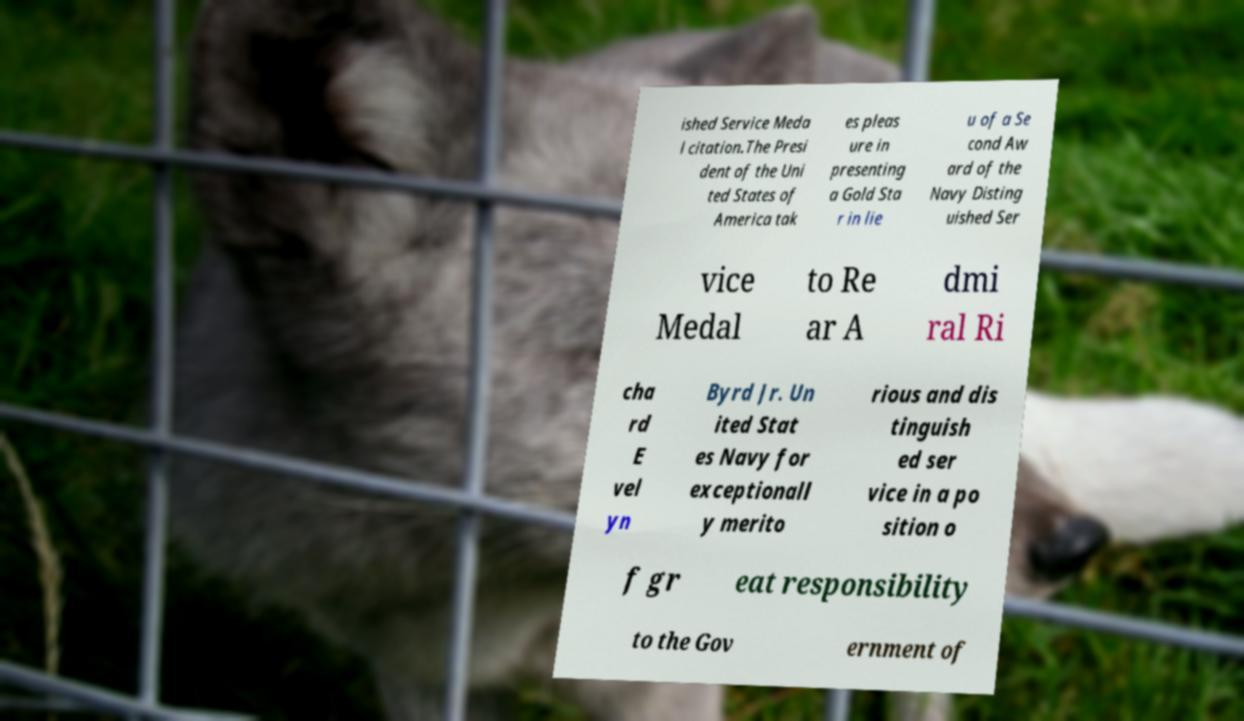There's text embedded in this image that I need extracted. Can you transcribe it verbatim? ished Service Meda l citation.The Presi dent of the Uni ted States of America tak es pleas ure in presenting a Gold Sta r in lie u of a Se cond Aw ard of the Navy Disting uished Ser vice Medal to Re ar A dmi ral Ri cha rd E vel yn Byrd Jr. Un ited Stat es Navy for exceptionall y merito rious and dis tinguish ed ser vice in a po sition o f gr eat responsibility to the Gov ernment of 